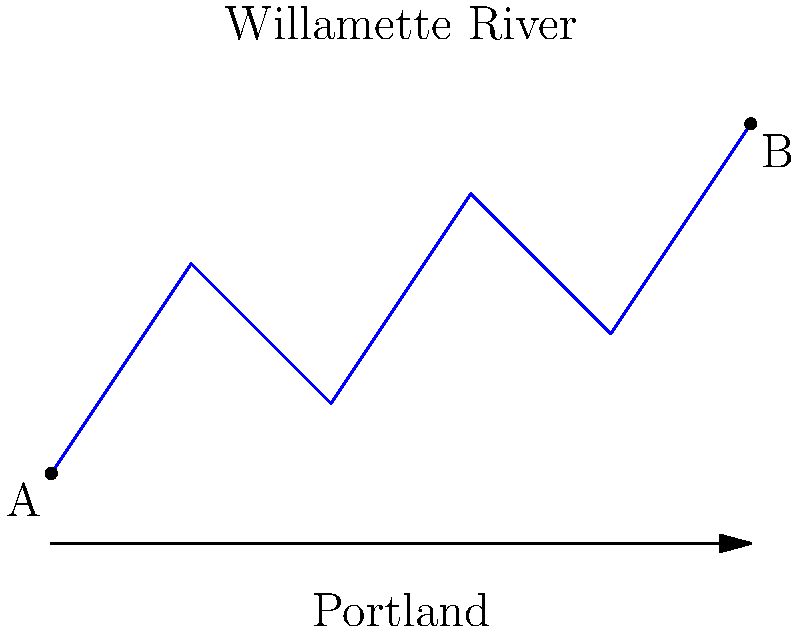Consider the path of the Willamette River through Portland as shown in the diagram. If we create a space by connecting points A and B with a straight line, what is the fundamental group of the resulting space? How does this relate to the urban development around Henry Ford's Restaurant? Let's approach this step-by-step:

1) The path of the Willamette River, combined with the straight line connecting A and B, forms a closed loop.

2) This closed loop divides the plane into two regions: the area inside the loop and the area outside the loop.

3) In topology, this configuration is homeomorphic to a circle $S^1$.

4) The fundamental group of a circle $S^1$ is isomorphic to the integers under addition, denoted as $\pi_1(S^1) \cong \mathbb{Z}$.

5) This means that the space allows for an infinite number of distinct loops that cannot be continuously deformed into each other.

6) In the context of Portland's urban development:
   - Each integer in $\mathbb{Z}$ could represent a distinct route around the river.
   - The development of areas like the one around Henry Ford's Restaurant would be influenced by these possible routes.
   - The topology suggests that there are multiple, distinct ways to navigate around the river, which could reflect the layout of streets and neighborhoods in Portland.

7) The non-trivial fundamental group indicates that the river creates a significant topological feature in the city's layout, potentially influencing the distribution of landmarks like Henry Ford's Restaurant.
Answer: $\pi_1(S^1) \cong \mathbb{Z}$ 